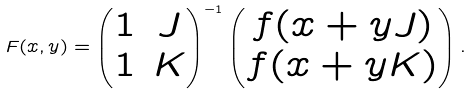<formula> <loc_0><loc_0><loc_500><loc_500>F ( x , y ) = \left ( \begin{matrix} 1 & J \\ 1 & K \end{matrix} \right ) ^ { - 1 } \left ( \begin{matrix} f ( x + y J ) \\ f ( x + y K ) \end{matrix} \right ) .</formula> 